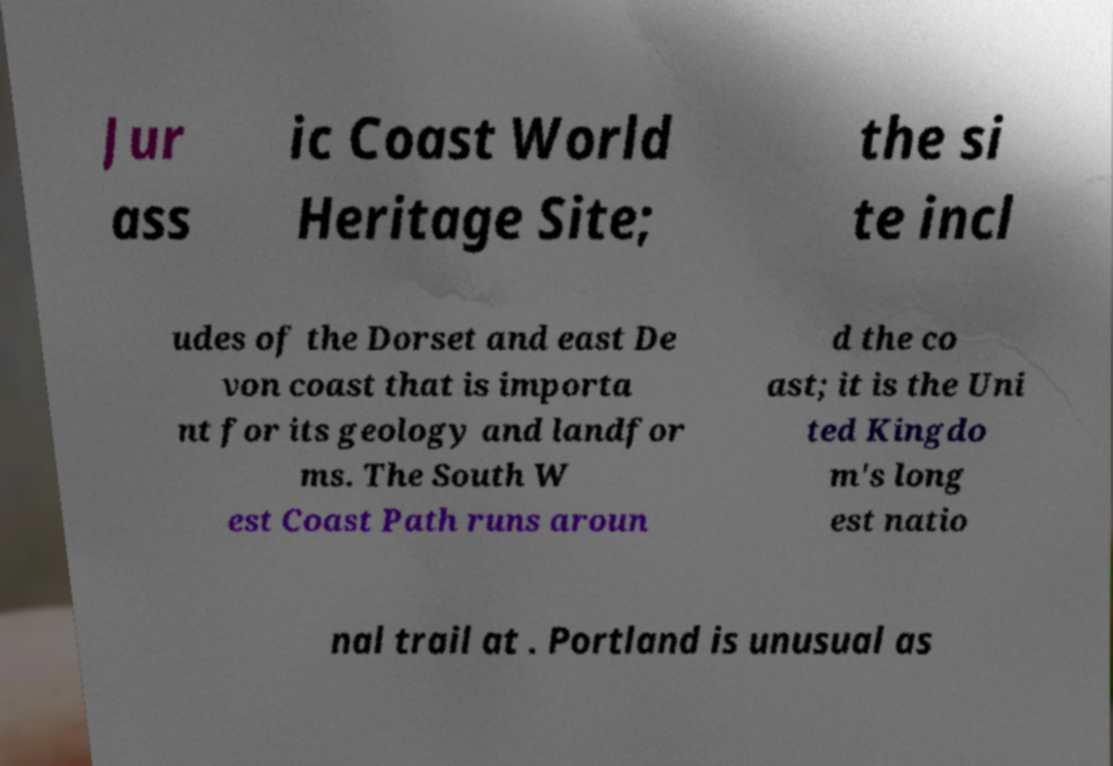There's text embedded in this image that I need extracted. Can you transcribe it verbatim? Jur ass ic Coast World Heritage Site; the si te incl udes of the Dorset and east De von coast that is importa nt for its geology and landfor ms. The South W est Coast Path runs aroun d the co ast; it is the Uni ted Kingdo m's long est natio nal trail at . Portland is unusual as 